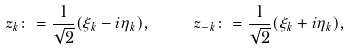Convert formula to latex. <formula><loc_0><loc_0><loc_500><loc_500>\ z _ { k } \colon = \frac { 1 } { \sqrt { 2 } } ( \xi _ { k } - i \eta _ { k } ) , \quad \ z _ { - k } \colon = \frac { 1 } { \sqrt { 2 } } ( \xi _ { k } + i \eta _ { k } ) ,</formula> 